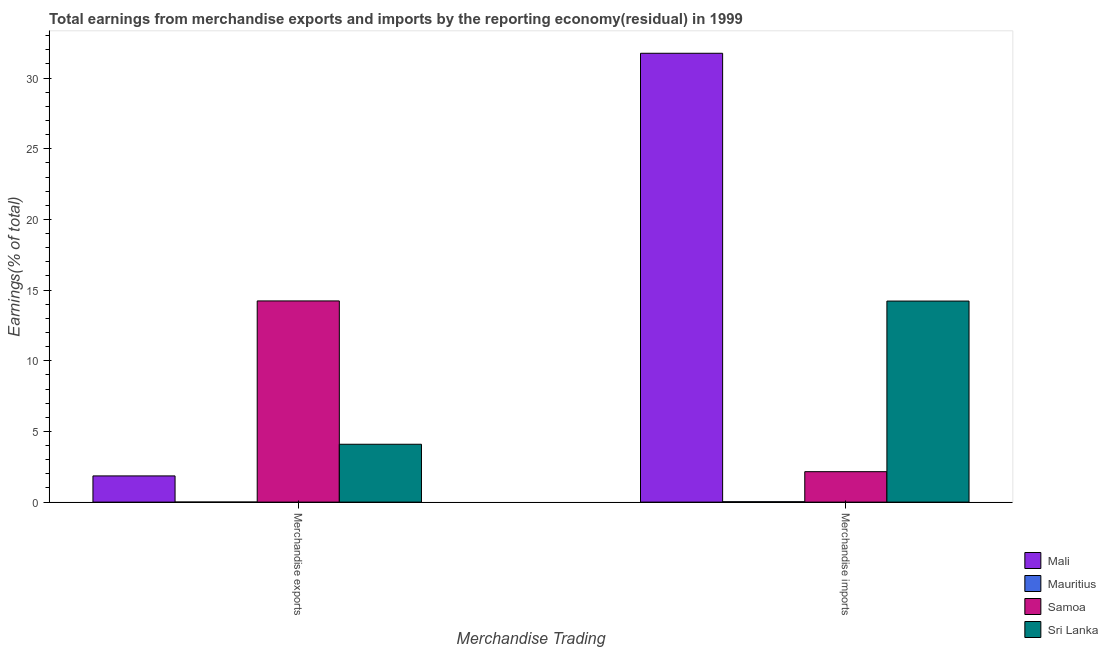How many groups of bars are there?
Offer a terse response. 2. Are the number of bars per tick equal to the number of legend labels?
Your answer should be compact. Yes. Are the number of bars on each tick of the X-axis equal?
Give a very brief answer. Yes. What is the label of the 1st group of bars from the left?
Provide a succinct answer. Merchandise exports. What is the earnings from merchandise imports in Mali?
Your response must be concise. 31.76. Across all countries, what is the maximum earnings from merchandise imports?
Your response must be concise. 31.76. Across all countries, what is the minimum earnings from merchandise exports?
Keep it short and to the point. 0.01. In which country was the earnings from merchandise exports maximum?
Ensure brevity in your answer.  Samoa. In which country was the earnings from merchandise exports minimum?
Offer a terse response. Mauritius. What is the total earnings from merchandise imports in the graph?
Provide a short and direct response. 48.16. What is the difference between the earnings from merchandise exports in Sri Lanka and that in Mali?
Your answer should be very brief. 2.24. What is the difference between the earnings from merchandise imports in Sri Lanka and the earnings from merchandise exports in Mauritius?
Give a very brief answer. 14.22. What is the average earnings from merchandise exports per country?
Give a very brief answer. 5.05. What is the difference between the earnings from merchandise imports and earnings from merchandise exports in Sri Lanka?
Ensure brevity in your answer.  10.13. In how many countries, is the earnings from merchandise imports greater than 18 %?
Provide a succinct answer. 1. What is the ratio of the earnings from merchandise exports in Sri Lanka to that in Mauritius?
Your answer should be very brief. 769.73. What does the 2nd bar from the left in Merchandise exports represents?
Offer a very short reply. Mauritius. What does the 1st bar from the right in Merchandise imports represents?
Your response must be concise. Sri Lanka. Are all the bars in the graph horizontal?
Offer a very short reply. No. Are the values on the major ticks of Y-axis written in scientific E-notation?
Your response must be concise. No. Does the graph contain grids?
Your answer should be compact. No. How many legend labels are there?
Your response must be concise. 4. What is the title of the graph?
Ensure brevity in your answer.  Total earnings from merchandise exports and imports by the reporting economy(residual) in 1999. Does "Andorra" appear as one of the legend labels in the graph?
Your answer should be very brief. No. What is the label or title of the X-axis?
Make the answer very short. Merchandise Trading. What is the label or title of the Y-axis?
Your response must be concise. Earnings(% of total). What is the Earnings(% of total) of Mali in Merchandise exports?
Ensure brevity in your answer.  1.85. What is the Earnings(% of total) of Mauritius in Merchandise exports?
Give a very brief answer. 0.01. What is the Earnings(% of total) of Samoa in Merchandise exports?
Your answer should be compact. 14.24. What is the Earnings(% of total) of Sri Lanka in Merchandise exports?
Make the answer very short. 4.09. What is the Earnings(% of total) of Mali in Merchandise imports?
Your response must be concise. 31.76. What is the Earnings(% of total) of Mauritius in Merchandise imports?
Provide a succinct answer. 0.03. What is the Earnings(% of total) of Samoa in Merchandise imports?
Provide a succinct answer. 2.15. What is the Earnings(% of total) in Sri Lanka in Merchandise imports?
Offer a terse response. 14.23. Across all Merchandise Trading, what is the maximum Earnings(% of total) of Mali?
Offer a very short reply. 31.76. Across all Merchandise Trading, what is the maximum Earnings(% of total) of Mauritius?
Keep it short and to the point. 0.03. Across all Merchandise Trading, what is the maximum Earnings(% of total) in Samoa?
Provide a succinct answer. 14.24. Across all Merchandise Trading, what is the maximum Earnings(% of total) in Sri Lanka?
Provide a short and direct response. 14.23. Across all Merchandise Trading, what is the minimum Earnings(% of total) of Mali?
Offer a very short reply. 1.85. Across all Merchandise Trading, what is the minimum Earnings(% of total) of Mauritius?
Offer a very short reply. 0.01. Across all Merchandise Trading, what is the minimum Earnings(% of total) in Samoa?
Offer a very short reply. 2.15. Across all Merchandise Trading, what is the minimum Earnings(% of total) in Sri Lanka?
Your answer should be very brief. 4.09. What is the total Earnings(% of total) in Mali in the graph?
Offer a very short reply. 33.61. What is the total Earnings(% of total) of Mauritius in the graph?
Provide a short and direct response. 0.03. What is the total Earnings(% of total) in Samoa in the graph?
Make the answer very short. 16.39. What is the total Earnings(% of total) of Sri Lanka in the graph?
Offer a very short reply. 18.32. What is the difference between the Earnings(% of total) in Mali in Merchandise exports and that in Merchandise imports?
Provide a succinct answer. -29.9. What is the difference between the Earnings(% of total) in Mauritius in Merchandise exports and that in Merchandise imports?
Your answer should be compact. -0.02. What is the difference between the Earnings(% of total) of Samoa in Merchandise exports and that in Merchandise imports?
Make the answer very short. 12.08. What is the difference between the Earnings(% of total) of Sri Lanka in Merchandise exports and that in Merchandise imports?
Provide a succinct answer. -10.13. What is the difference between the Earnings(% of total) of Mali in Merchandise exports and the Earnings(% of total) of Mauritius in Merchandise imports?
Your answer should be compact. 1.83. What is the difference between the Earnings(% of total) in Mali in Merchandise exports and the Earnings(% of total) in Samoa in Merchandise imports?
Your answer should be very brief. -0.3. What is the difference between the Earnings(% of total) in Mali in Merchandise exports and the Earnings(% of total) in Sri Lanka in Merchandise imports?
Offer a very short reply. -12.37. What is the difference between the Earnings(% of total) in Mauritius in Merchandise exports and the Earnings(% of total) in Samoa in Merchandise imports?
Make the answer very short. -2.15. What is the difference between the Earnings(% of total) in Mauritius in Merchandise exports and the Earnings(% of total) in Sri Lanka in Merchandise imports?
Offer a terse response. -14.22. What is the difference between the Earnings(% of total) in Samoa in Merchandise exports and the Earnings(% of total) in Sri Lanka in Merchandise imports?
Make the answer very short. 0.01. What is the average Earnings(% of total) of Mali per Merchandise Trading?
Keep it short and to the point. 16.81. What is the average Earnings(% of total) in Mauritius per Merchandise Trading?
Offer a very short reply. 0.02. What is the average Earnings(% of total) in Samoa per Merchandise Trading?
Provide a succinct answer. 8.19. What is the average Earnings(% of total) in Sri Lanka per Merchandise Trading?
Your answer should be very brief. 9.16. What is the difference between the Earnings(% of total) in Mali and Earnings(% of total) in Mauritius in Merchandise exports?
Keep it short and to the point. 1.85. What is the difference between the Earnings(% of total) of Mali and Earnings(% of total) of Samoa in Merchandise exports?
Offer a very short reply. -12.38. What is the difference between the Earnings(% of total) of Mali and Earnings(% of total) of Sri Lanka in Merchandise exports?
Provide a short and direct response. -2.24. What is the difference between the Earnings(% of total) in Mauritius and Earnings(% of total) in Samoa in Merchandise exports?
Keep it short and to the point. -14.23. What is the difference between the Earnings(% of total) of Mauritius and Earnings(% of total) of Sri Lanka in Merchandise exports?
Make the answer very short. -4.09. What is the difference between the Earnings(% of total) in Samoa and Earnings(% of total) in Sri Lanka in Merchandise exports?
Give a very brief answer. 10.14. What is the difference between the Earnings(% of total) of Mali and Earnings(% of total) of Mauritius in Merchandise imports?
Keep it short and to the point. 31.73. What is the difference between the Earnings(% of total) of Mali and Earnings(% of total) of Samoa in Merchandise imports?
Make the answer very short. 29.6. What is the difference between the Earnings(% of total) in Mali and Earnings(% of total) in Sri Lanka in Merchandise imports?
Offer a very short reply. 17.53. What is the difference between the Earnings(% of total) in Mauritius and Earnings(% of total) in Samoa in Merchandise imports?
Offer a terse response. -2.13. What is the difference between the Earnings(% of total) of Mauritius and Earnings(% of total) of Sri Lanka in Merchandise imports?
Give a very brief answer. -14.2. What is the difference between the Earnings(% of total) of Samoa and Earnings(% of total) of Sri Lanka in Merchandise imports?
Your response must be concise. -12.07. What is the ratio of the Earnings(% of total) of Mali in Merchandise exports to that in Merchandise imports?
Give a very brief answer. 0.06. What is the ratio of the Earnings(% of total) in Mauritius in Merchandise exports to that in Merchandise imports?
Your answer should be compact. 0.19. What is the ratio of the Earnings(% of total) of Samoa in Merchandise exports to that in Merchandise imports?
Your answer should be very brief. 6.61. What is the ratio of the Earnings(% of total) of Sri Lanka in Merchandise exports to that in Merchandise imports?
Your answer should be very brief. 0.29. What is the difference between the highest and the second highest Earnings(% of total) in Mali?
Offer a very short reply. 29.9. What is the difference between the highest and the second highest Earnings(% of total) of Mauritius?
Offer a very short reply. 0.02. What is the difference between the highest and the second highest Earnings(% of total) in Samoa?
Your response must be concise. 12.08. What is the difference between the highest and the second highest Earnings(% of total) of Sri Lanka?
Your answer should be very brief. 10.13. What is the difference between the highest and the lowest Earnings(% of total) in Mali?
Your answer should be very brief. 29.9. What is the difference between the highest and the lowest Earnings(% of total) in Mauritius?
Your answer should be compact. 0.02. What is the difference between the highest and the lowest Earnings(% of total) of Samoa?
Provide a succinct answer. 12.08. What is the difference between the highest and the lowest Earnings(% of total) of Sri Lanka?
Ensure brevity in your answer.  10.13. 